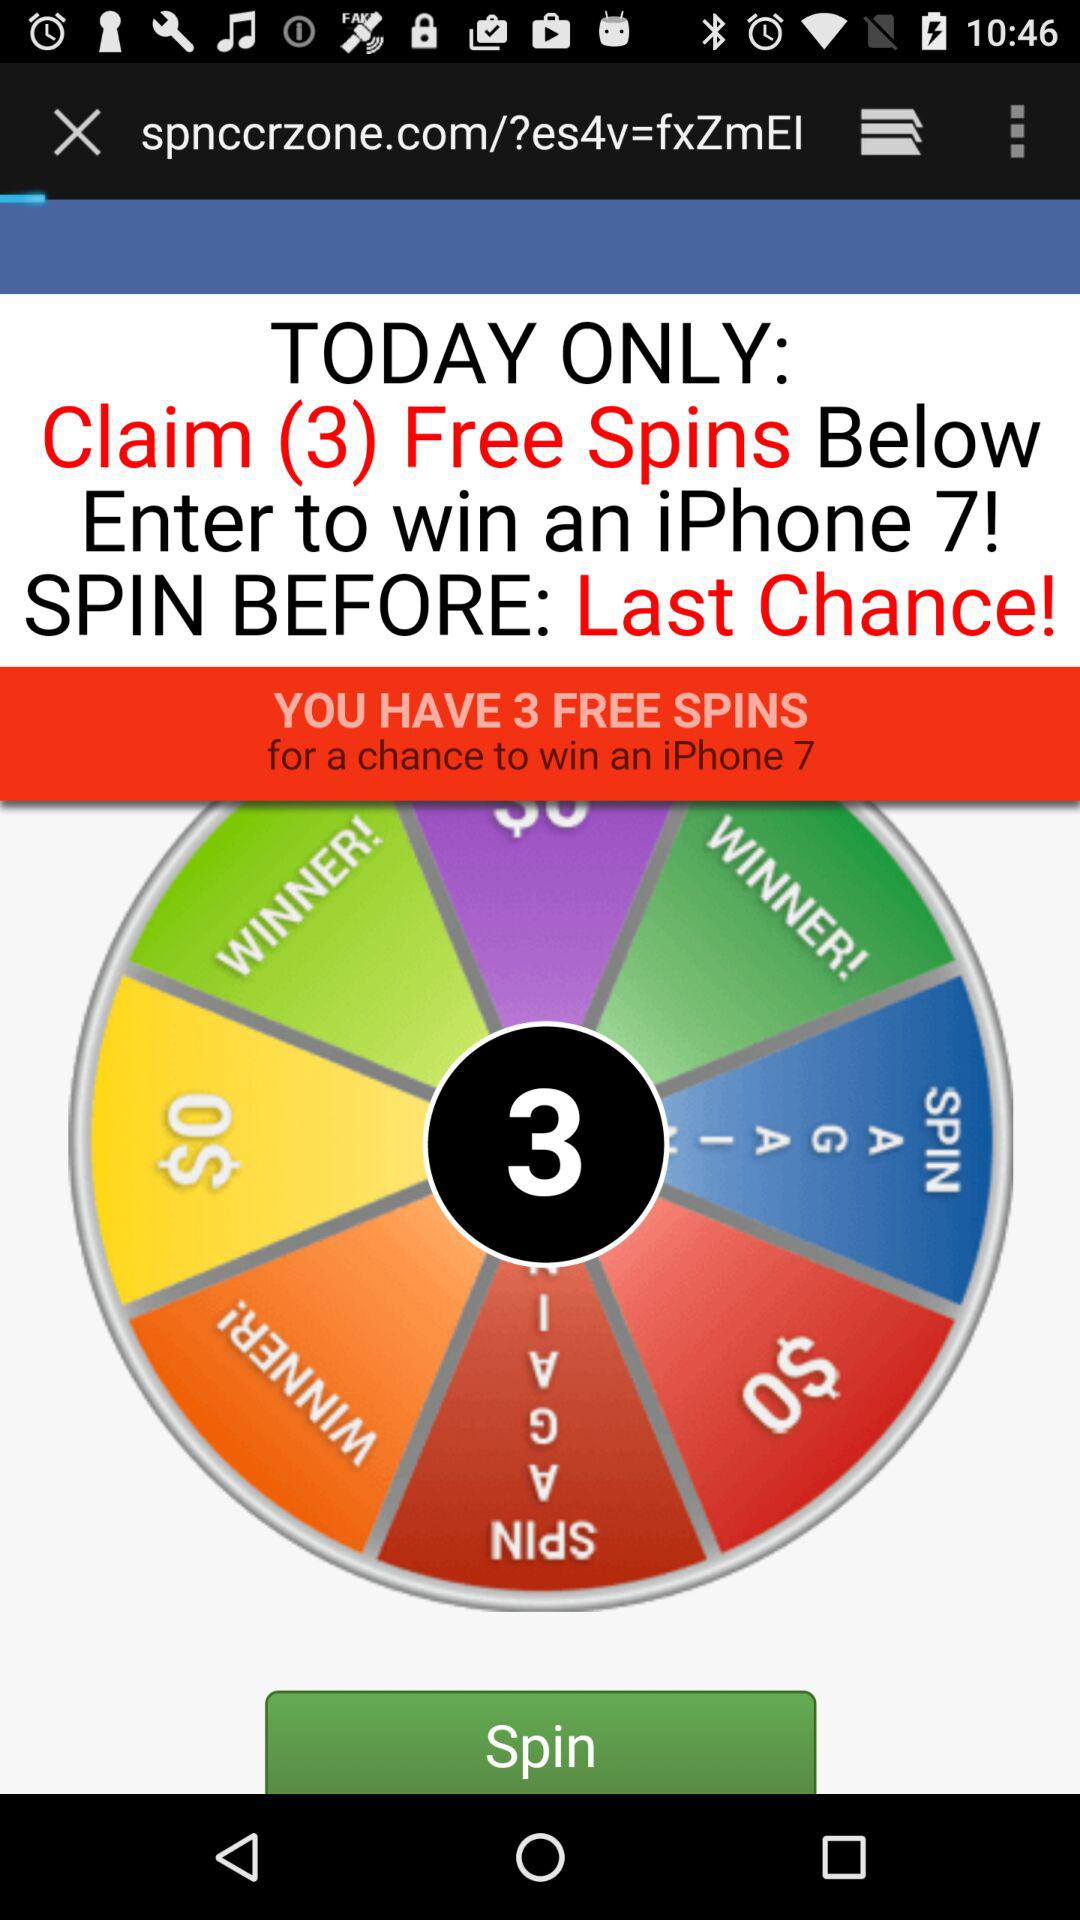How many free spins do I have?
Answer the question using a single word or phrase. 3 